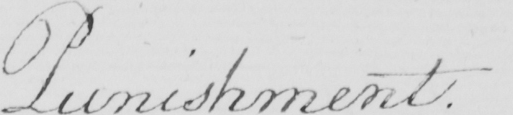Please provide the text content of this handwritten line. Punishment . 